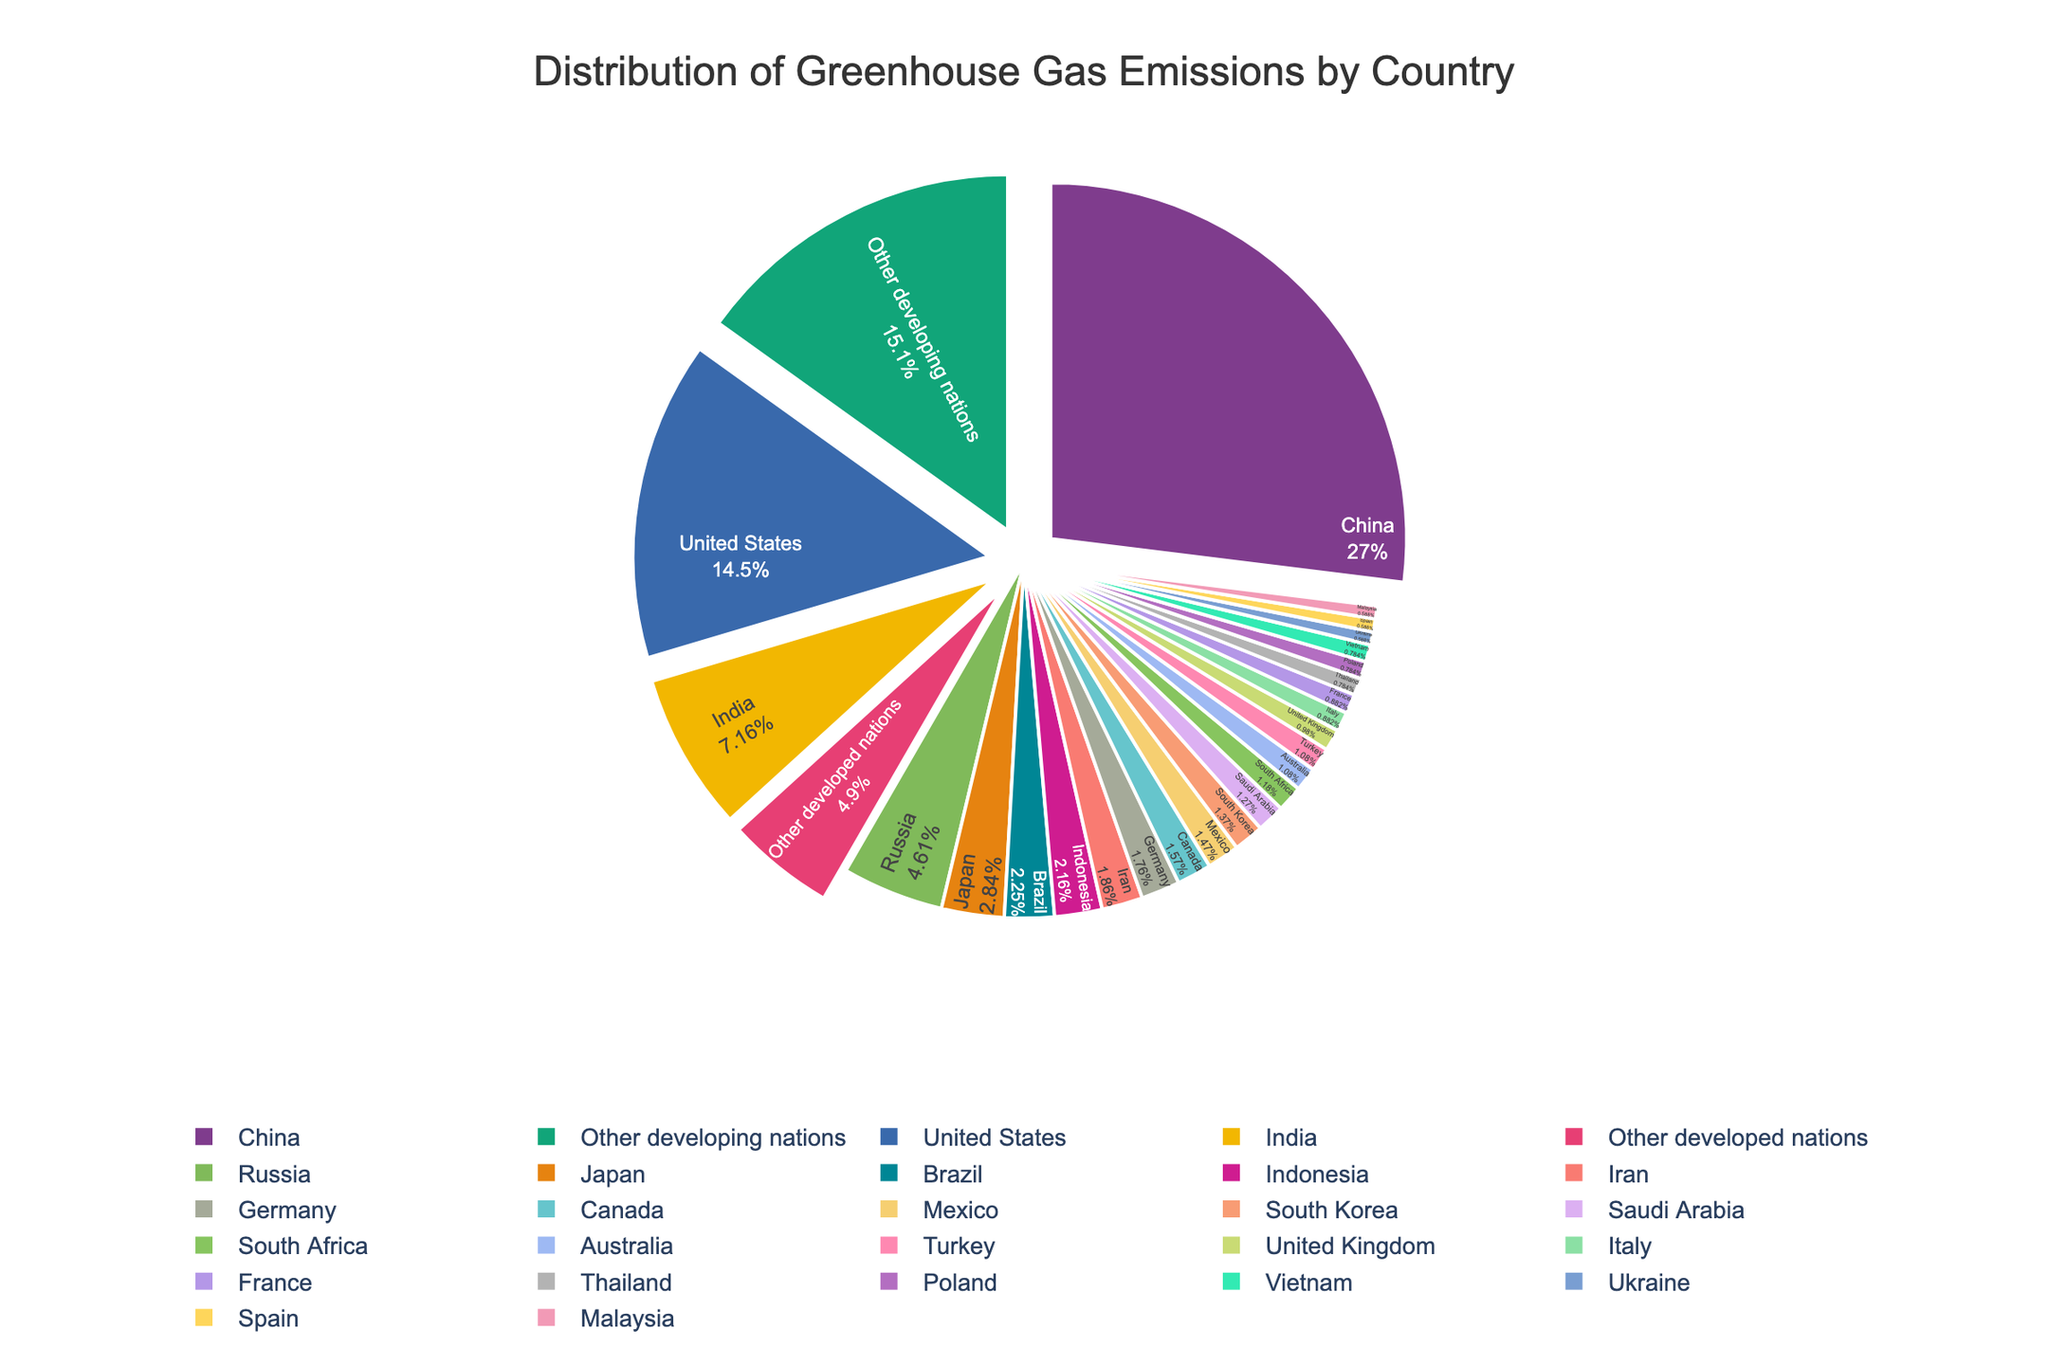Which country is responsible for the highest percentage of greenhouse gas emissions? The pie chart shows different countries with their respective percentage contributions to greenhouse gas emissions. By identifying the largest slice, which is labeled “China” at 27.5%, we determine that China is responsible for the highest percentage.
Answer: China What is the combined percentage contribution of China, the United States, and India? To find the combined percentage contribution, add the percentages for China (27.5%), the United States (14.8%), and India (7.3%). The sum is 27.5 + 14.8 + 7.3 = 49.6%.
Answer: 49.6% Which countries have an equal or lower contribution than 1.1%? By observing the slices with labels and their corresponding percentages, we identify the countries which have values 1.1% or lower: United Kingdom (1.0%), Italy (0.9%), France (0.9%), Thailand (0.8%), Poland (0.8%), Vietnam (0.8%), Ukraine (0.6%), Spain (0.6%), and Malaysia (0.6%).
Answer: United Kingdom, Italy, France, Thailand, Poland, Vietnam, Ukraine, Spain, Malaysia What is the visual difference between “Other developing nations” and “Other developed nations” in terms of slice size and color? Based on the pie chart’s visual representation, "Other developing nations" has a larger slice compared to "Other developed nations". Additionally, "Other developing nations" typically appears in a distinct color that is visually larger, indicating 15.4%, whereas "Other developed nations" has a smaller slice at 5.0%.
Answer: Larger slice for "Other developing nations", distinct colors Compare Brazil's percentage contribution to greenhouse gas emissions with that of Indonesia. Which is higher and by how much? Brazil contributes 2.3% and Indonesia contributes 2.2%. Subtracting Indonesia's percentage from Brazil's percentage gives 2.3% - 2.2% = 0.1%. Therefore, Brazil's contribution is higher by 0.1%.
Answer: Brazil by 0.1% What is the total percentage contribution of countries contributing less than 2% each? Identify and add up the percentages of the countries with values less than 2%: Germany (1.8%), Canada (1.6%), Mexico (1.5%), South Korea (1.4%), Saudi Arabia (1.3%), South Africa (1.2%), Turkey (1.1%), Australia (1.1%), United Kingdom (1.0%), Italy (0.9%), France (0.9%), Thailand (0.8%), Poland (0.8%), Vietnam (0.8%), Ukraine (0.6%), Spain (0.6%), Malaysia (0.6%), Other developing nations (15.4%), and Other developed nations (5.0%). The total is 1.8+1.6+1.5+1.4+1.3+1.2+1.1+1.1+1.0+0.9+0.9+0.8+0.8+0.8+0.6+0.6+0.6+15.4+5.0 = 42.4%.
Answer: 42.4% Is the total percentage contribution of the top 4 emitters greater than that of all other countries combined? The top 4 emitters are China (27.5%), United States (14.8%), India (7.3%), and Russia (4.7%). Their total contribution is 27.5+14.8+7.3+4.7 = 54.3%. The total percentage contribution of all other countries is 100% - 54.3% = 45.7%. Thus, the top 4 emitters’ total is greater.
Answer: Yes How does the percentage contribution of Japan compare to that of Germany and Canada combined? Japan contributes 2.9%. Germany's and Canada’s contributions are 1.8% and 1.6% respectively. Their combined contribution is 1.8 + 1.6 = 3.4%. Comparing, Japan’s contribution (2.9%) is less than the combined contribution of Germany and Canada (3.4%).
Answer: Less by 0.5% 